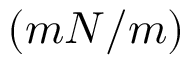<formula> <loc_0><loc_0><loc_500><loc_500>( m N / m )</formula> 